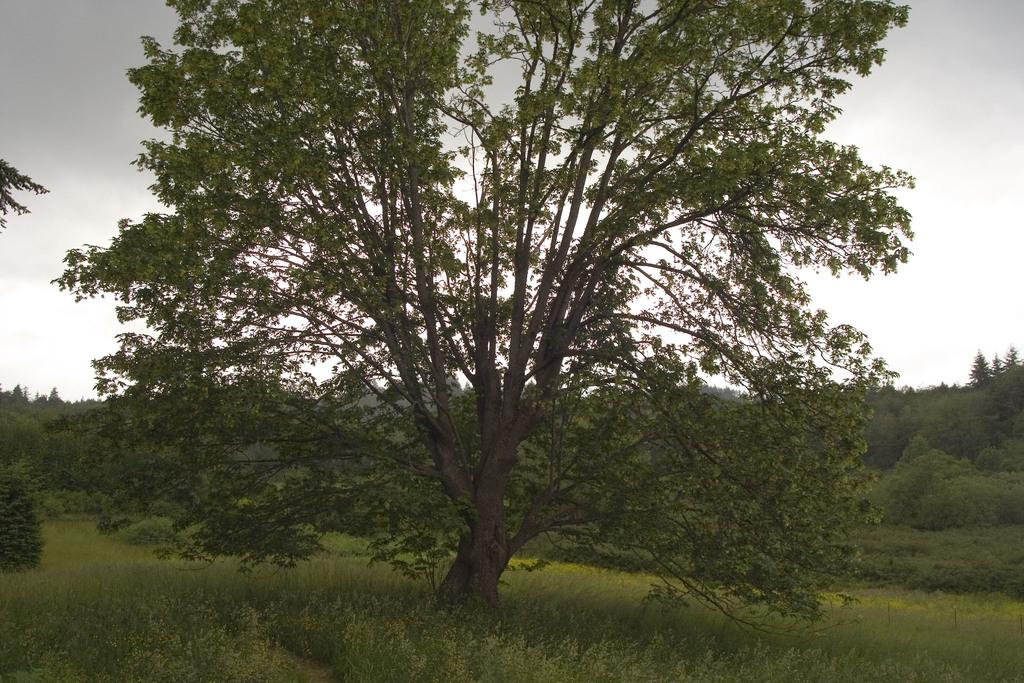What is the main subject in the foreground of the image? There is a tree in the foreground of the image. What type of terrain is the tree located on? The tree is on grassy land. What can be seen in the background of the image? There is greenery and the sky visible in the background of the image. What is the condition of the sky in the image? Clouds are present in the sky. What type of debt is being discussed in the image? There is no mention of debt in the image; it features a tree on grassy land with greenery and clouds in the background. How many chickens can be seen in the image? There are no chickens present in the image. 